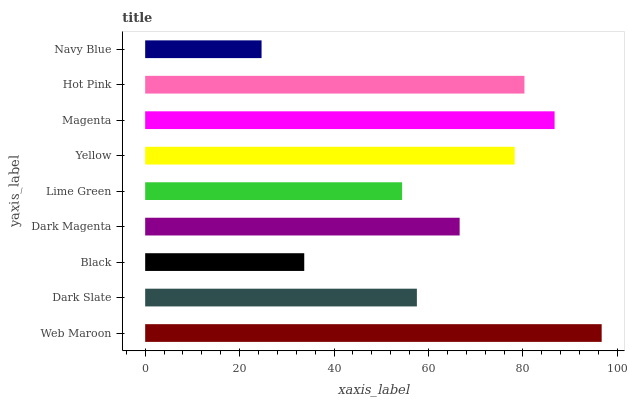Is Navy Blue the minimum?
Answer yes or no. Yes. Is Web Maroon the maximum?
Answer yes or no. Yes. Is Dark Slate the minimum?
Answer yes or no. No. Is Dark Slate the maximum?
Answer yes or no. No. Is Web Maroon greater than Dark Slate?
Answer yes or no. Yes. Is Dark Slate less than Web Maroon?
Answer yes or no. Yes. Is Dark Slate greater than Web Maroon?
Answer yes or no. No. Is Web Maroon less than Dark Slate?
Answer yes or no. No. Is Dark Magenta the high median?
Answer yes or no. Yes. Is Dark Magenta the low median?
Answer yes or no. Yes. Is Navy Blue the high median?
Answer yes or no. No. Is Navy Blue the low median?
Answer yes or no. No. 